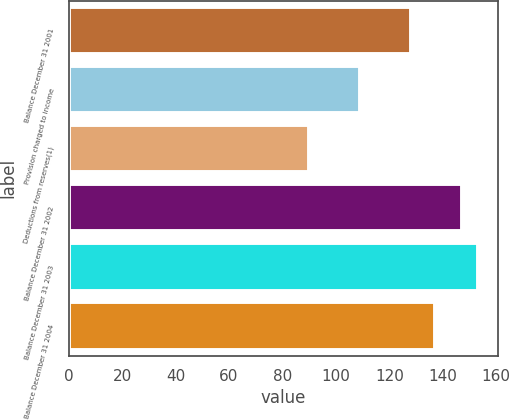Convert chart. <chart><loc_0><loc_0><loc_500><loc_500><bar_chart><fcel>Balance December 31 2001<fcel>Provision charged to income<fcel>Deductions from reserves(1)<fcel>Balance December 31 2002<fcel>Balance December 31 2003<fcel>Balance December 31 2004<nl><fcel>128<fcel>109<fcel>90<fcel>147<fcel>153<fcel>137<nl></chart> 